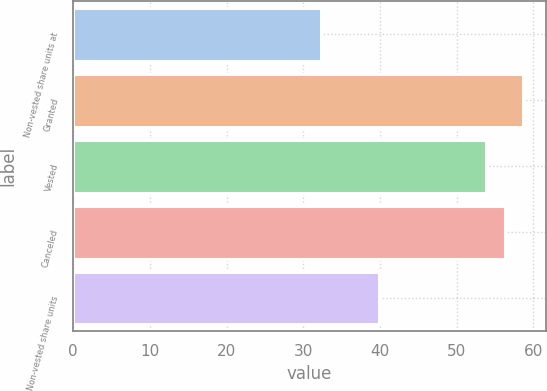<chart> <loc_0><loc_0><loc_500><loc_500><bar_chart><fcel>Non-vested share units at<fcel>Granted<fcel>Vested<fcel>Canceled<fcel>Non-vested share units<nl><fcel>32.36<fcel>58.69<fcel>53.81<fcel>56.25<fcel>39.86<nl></chart> 